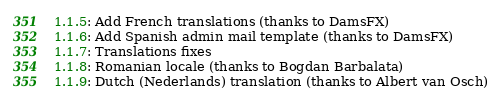Convert code to text. <code><loc_0><loc_0><loc_500><loc_500><_YAML_>1.1.5: Add French translations (thanks to DamsFX)
1.1.6: Add Spanish admin mail template (thanks to DamsFX)
1.1.7: Translations fixes
1.1.8: Romanian locale (thanks to Bogdan Barbalata)
1.1.9: Dutch (Nederlands) translation (thanks to Albert van Osch)
</code> 